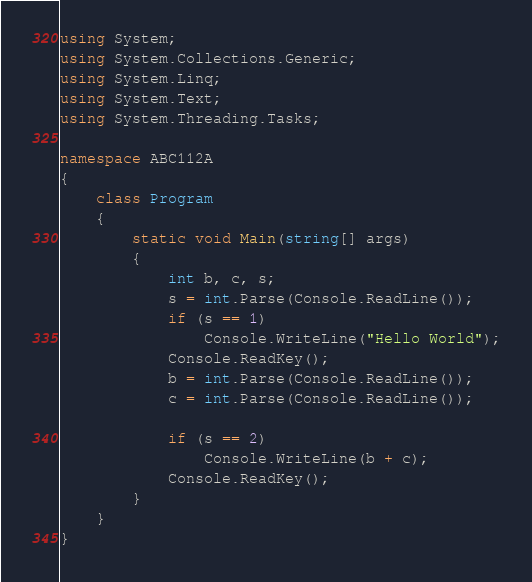<code> <loc_0><loc_0><loc_500><loc_500><_C#_>using System;
using System.Collections.Generic;
using System.Linq;
using System.Text;
using System.Threading.Tasks;

namespace ABC112A
{
    class Program
    {
        static void Main(string[] args)
        {
            int b, c, s;
            s = int.Parse(Console.ReadLine());
            if (s == 1)
                Console.WriteLine("Hello World");
            Console.ReadKey();
            b = int.Parse(Console.ReadLine());
            c = int.Parse(Console.ReadLine());
            
            if (s == 2)
                Console.WriteLine(b + c);
            Console.ReadKey();
        }
    }
}
</code> 